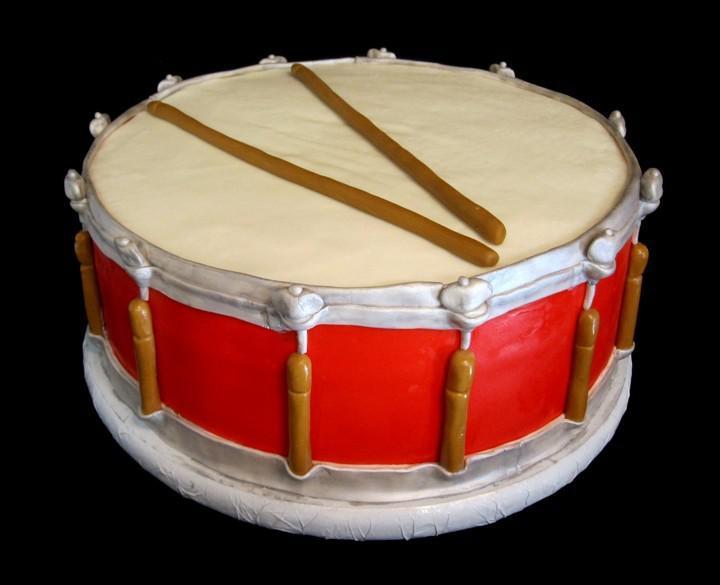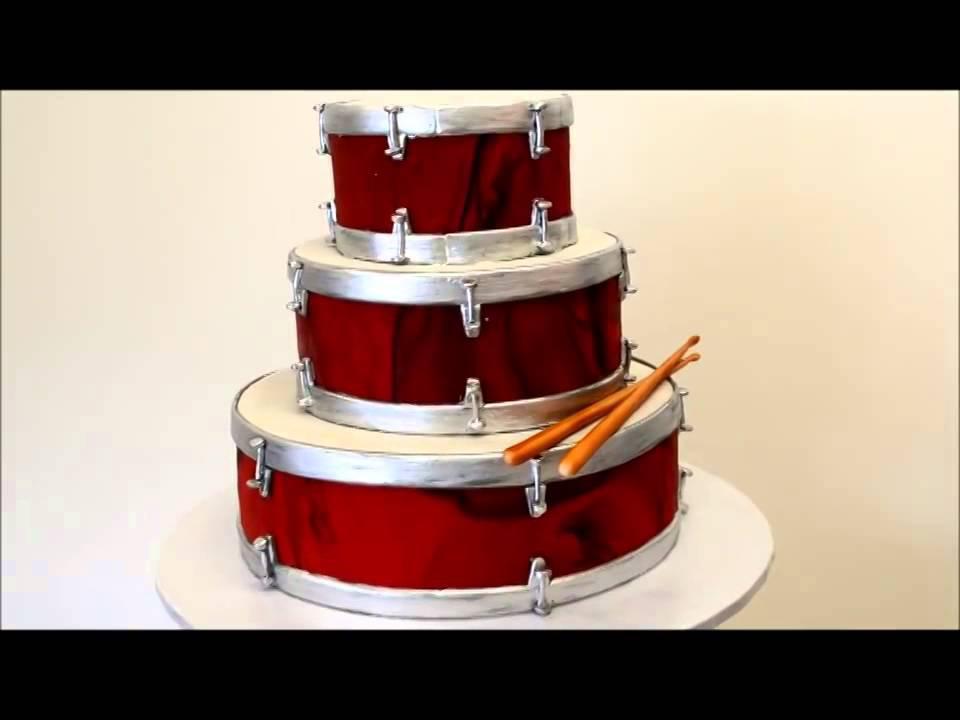The first image is the image on the left, the second image is the image on the right. Given the left and right images, does the statement "Both cakes are tiered." hold true? Answer yes or no. No. 